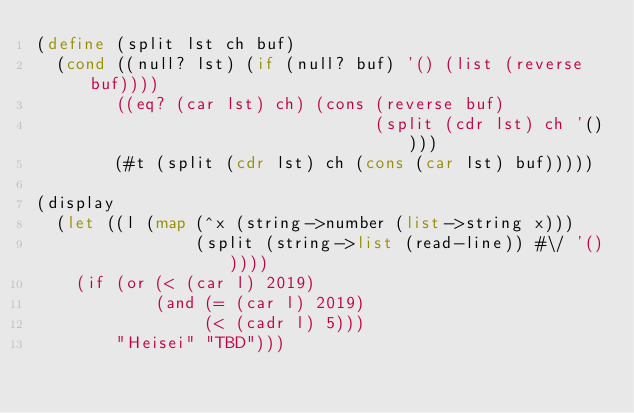<code> <loc_0><loc_0><loc_500><loc_500><_Scheme_>(define (split lst ch buf)
  (cond ((null? lst) (if (null? buf) '() (list (reverse buf))))
        ((eq? (car lst) ch) (cons (reverse buf)
                                  (split (cdr lst) ch '())))
        (#t (split (cdr lst) ch (cons (car lst) buf)))))

(display
  (let ((l (map (^x (string->number (list->string x)))
                (split (string->list (read-line)) #\/ '()))))
    (if (or (< (car l) 2019)
            (and (= (car l) 2019)
                 (< (cadr l) 5)))
        "Heisei" "TBD")))
</code> 